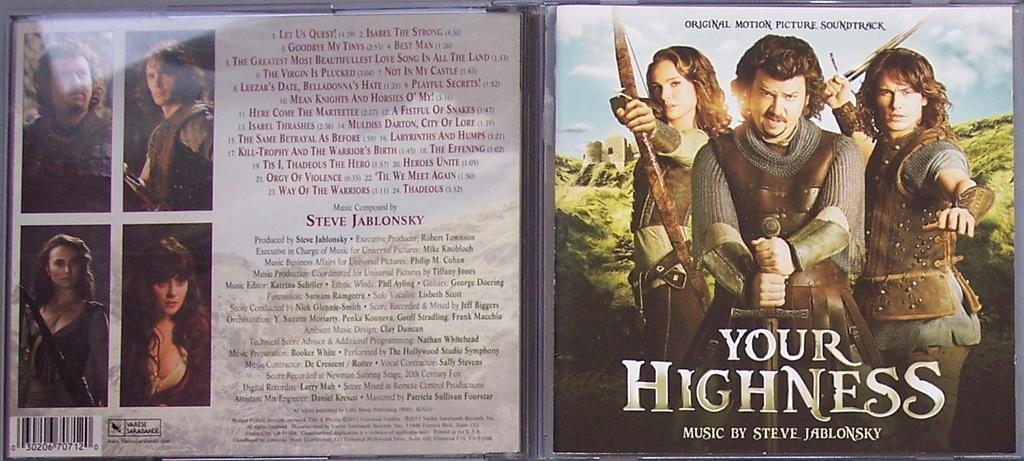<image>
Present a compact description of the photo's key features. A DVD os a film: "Your Highness, Music By Steve J..osky" 